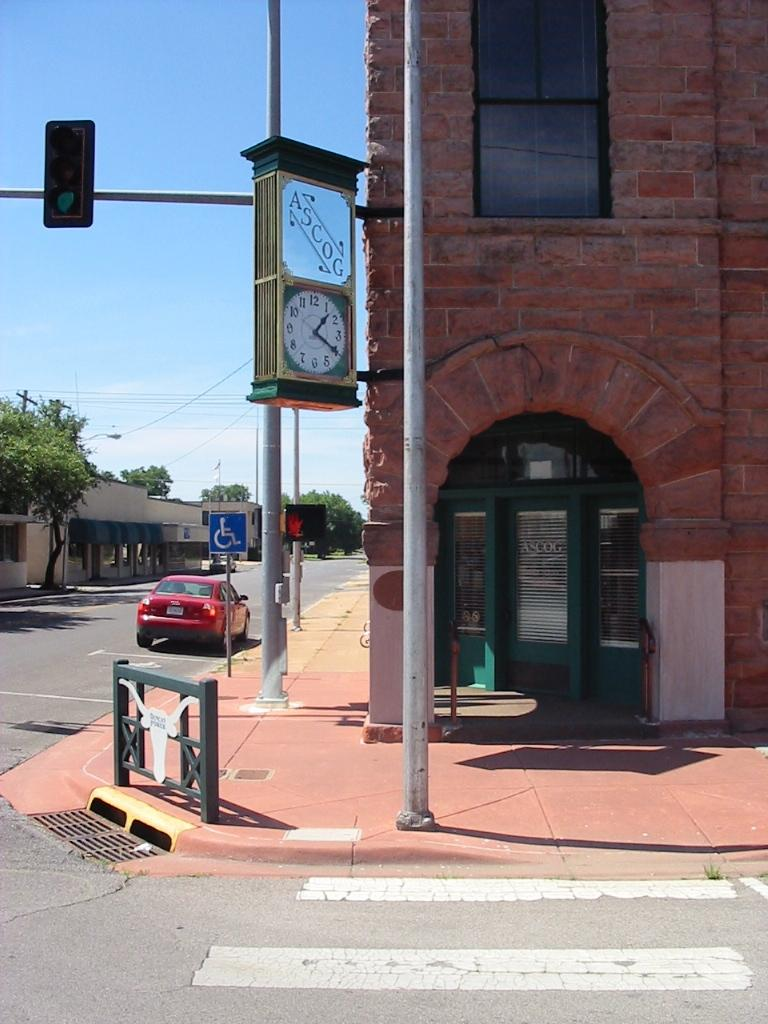<image>
Give a short and clear explanation of the subsequent image. A street corner with the business ASCOG in an old multi story brick building. 